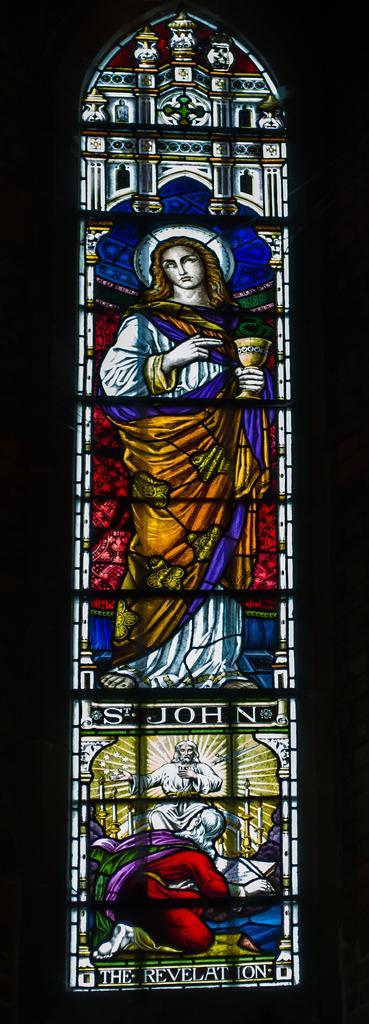In one or two sentences, can you explain what this image depicts? In this image, we can see depiction of persons and some text. 